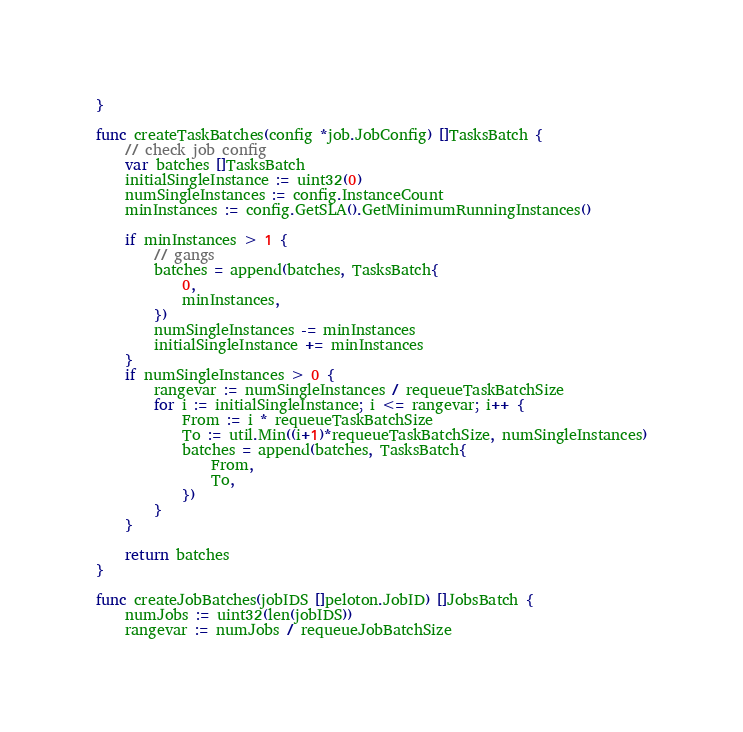Convert code to text. <code><loc_0><loc_0><loc_500><loc_500><_Go_>}

func createTaskBatches(config *job.JobConfig) []TasksBatch {
	// check job config
	var batches []TasksBatch
	initialSingleInstance := uint32(0)
	numSingleInstances := config.InstanceCount
	minInstances := config.GetSLA().GetMinimumRunningInstances()

	if minInstances > 1 {
		// gangs
		batches = append(batches, TasksBatch{
			0,
			minInstances,
		})
		numSingleInstances -= minInstances
		initialSingleInstance += minInstances
	}
	if numSingleInstances > 0 {
		rangevar := numSingleInstances / requeueTaskBatchSize
		for i := initialSingleInstance; i <= rangevar; i++ {
			From := i * requeueTaskBatchSize
			To := util.Min((i+1)*requeueTaskBatchSize, numSingleInstances)
			batches = append(batches, TasksBatch{
				From,
				To,
			})
		}
	}

	return batches
}

func createJobBatches(jobIDS []peloton.JobID) []JobsBatch {
	numJobs := uint32(len(jobIDS))
	rangevar := numJobs / requeueJobBatchSize</code> 